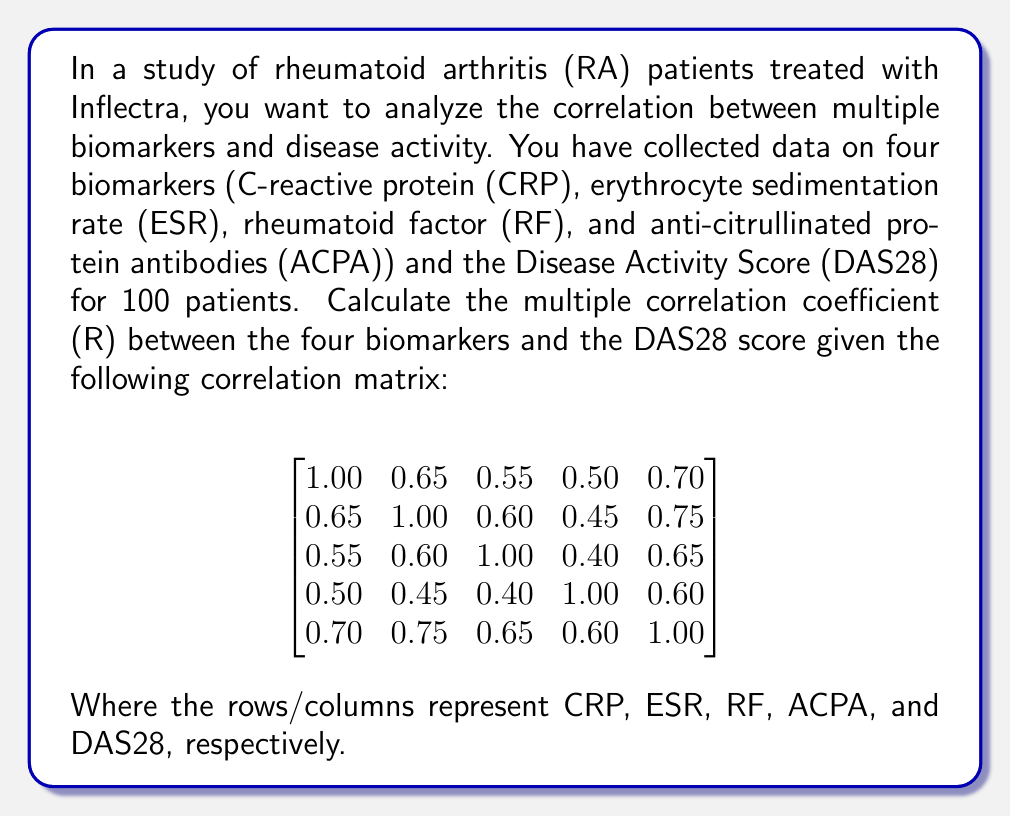Give your solution to this math problem. To calculate the multiple correlation coefficient (R) between the four biomarkers and the DAS28 score, we'll use the following steps:

1. First, we need to identify the correlation matrix between the predictor variables (biomarkers) and the correlation vector between the predictors and the dependent variable (DAS28).

   Correlation matrix of predictors (R_xx):
   $$
   R_{xx} = \begin{bmatrix}
   1.00 & 0.65 & 0.55 & 0.50 \\
   0.65 & 1.00 & 0.60 & 0.45 \\
   0.55 & 0.60 & 1.00 & 0.40 \\
   0.50 & 0.45 & 0.40 & 1.00
   \end{bmatrix}
   $$

   Correlation vector between predictors and DAS28 (r_xy):
   $$
   r_{xy} = \begin{bmatrix}
   0.70 \\
   0.75 \\
   0.65 \\
   0.60
   \end{bmatrix}
   $$

2. Calculate the inverse of R_xx:
   $$
   R_{xx}^{-1} = \begin{bmatrix}
   1.8018 & -0.7411 & -0.3411 & -0.2679 \\
   -0.7411 & 1.9464 & -0.5982 & -0.0893 \\
   -0.3411 & -0.5982 & 1.6964 & -0.0357 \\
   -0.2679 & -0.0893 & -0.0357 & 1.4286
   \end{bmatrix}
   $$

3. Calculate R^2 using the formula:
   $$R^2 = r_{xy}^T R_{xx}^{-1} r_{xy}$$

   $$
   R^2 = \begin{bmatrix}0.70 & 0.75 & 0.65 & 0.60\end{bmatrix}
   \begin{bmatrix}
   1.8018 & -0.7411 & -0.3411 & -0.2679 \\
   -0.7411 & 1.9464 & -0.5982 & -0.0893 \\
   -0.3411 & -0.5982 & 1.6964 & -0.0357 \\
   -0.2679 & -0.0893 & -0.0357 & 1.4286
   \end{bmatrix}
   \begin{bmatrix}0.70 \\ 0.75 \\ 0.65 \\ 0.60\end{bmatrix}
   $$

   $$R^2 = 0.7225$$

4. Calculate R by taking the square root of R^2:
   $$R = \sqrt{R^2} = \sqrt{0.7225} = 0.8500$$

Therefore, the multiple correlation coefficient (R) between the four biomarkers and the DAS28 score is 0.8500.
Answer: $R = 0.8500$ 